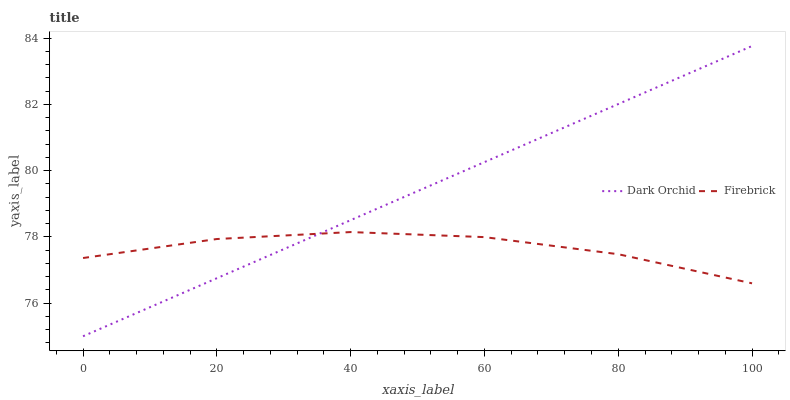Does Firebrick have the minimum area under the curve?
Answer yes or no. Yes. Does Dark Orchid have the maximum area under the curve?
Answer yes or no. Yes. Does Dark Orchid have the minimum area under the curve?
Answer yes or no. No. Is Dark Orchid the smoothest?
Answer yes or no. Yes. Is Firebrick the roughest?
Answer yes or no. Yes. Is Dark Orchid the roughest?
Answer yes or no. No. Does Dark Orchid have the lowest value?
Answer yes or no. Yes. Does Dark Orchid have the highest value?
Answer yes or no. Yes. Does Firebrick intersect Dark Orchid?
Answer yes or no. Yes. Is Firebrick less than Dark Orchid?
Answer yes or no. No. Is Firebrick greater than Dark Orchid?
Answer yes or no. No. 